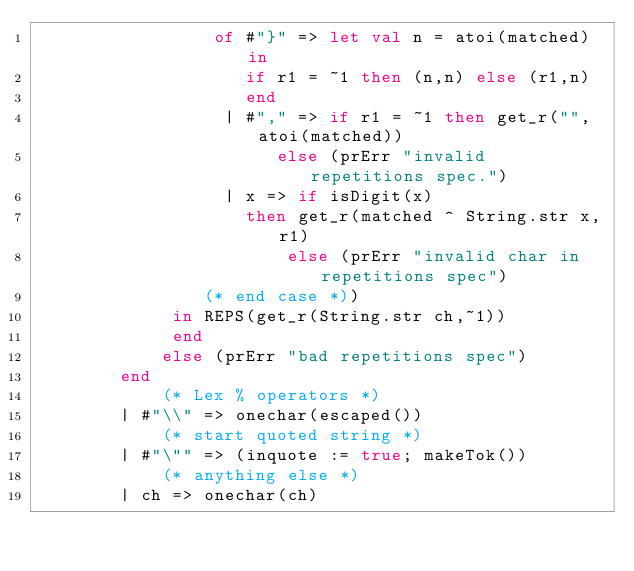<code> <loc_0><loc_0><loc_500><loc_500><_SML_>				 of #"}" => let val n = atoi(matched) in
					if r1 = ~1 then (n,n) else (r1,n)
					end
				  | #"," => if r1 = ~1 then get_r("",atoi(matched))
				       else (prErr "invalid repetitions spec.")
				  | x => if isDigit(x)
				    then get_r(matched ^ String.str x,r1)
			            else (prErr "invalid char in repetitions spec")
				(* end case *))
			 in REPS(get_r(String.str ch,~1))
			 end
			else (prErr "bad repetitions spec")
		end
			(* Lex % operators *)
		| #"\\" => onechar(escaped())
			(* start quoted string *)
		| #"\"" => (inquote := true; makeTok())
			(* anything else *)
		| ch => onechar(ch)</code> 